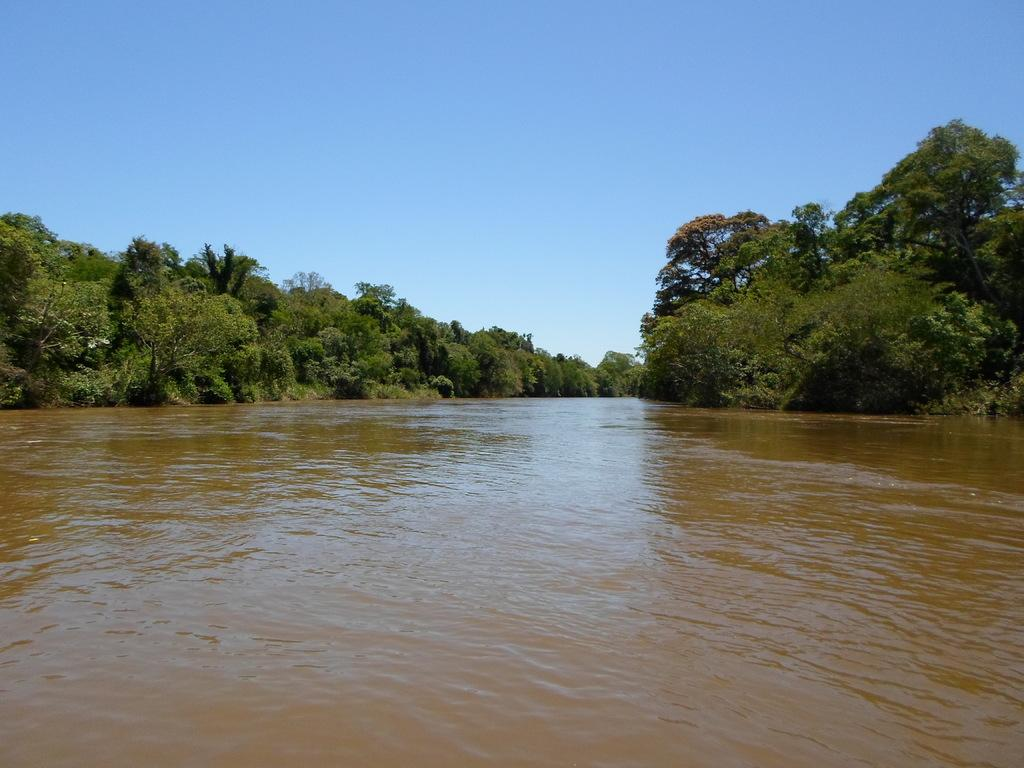What is the primary element visible in the image? There is a water surface visible in the image. What type of vegetation can be seen in the image? There are trees present in the image. What part of the natural environment is visible in the image? The sky is visible in the image. What type of knife can be seen floating on the water in the image? There is no knife present in the image; it only features a water surface, trees, and the sky. 